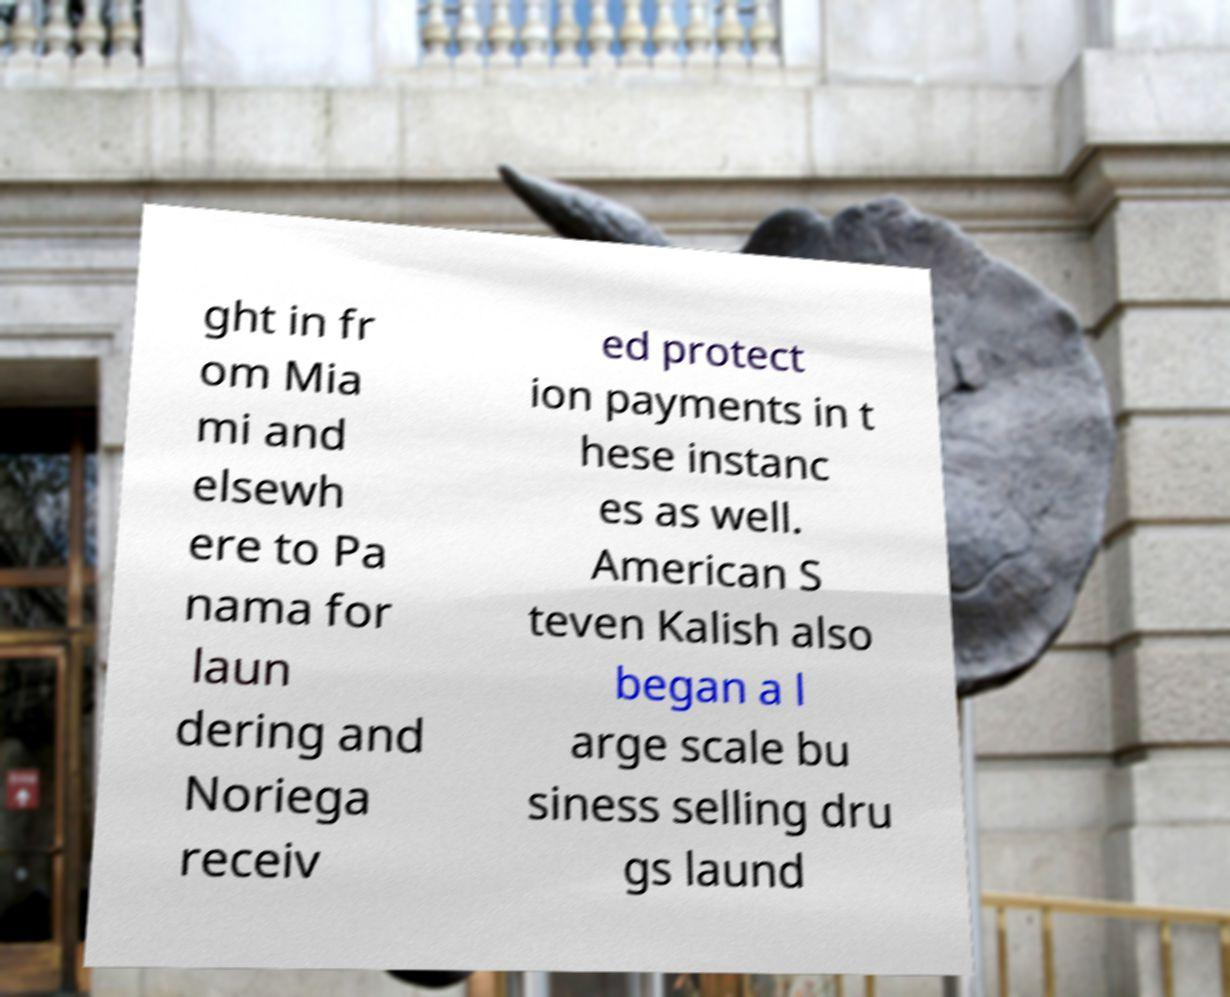Please identify and transcribe the text found in this image. ght in fr om Mia mi and elsewh ere to Pa nama for laun dering and Noriega receiv ed protect ion payments in t hese instanc es as well. American S teven Kalish also began a l arge scale bu siness selling dru gs laund 